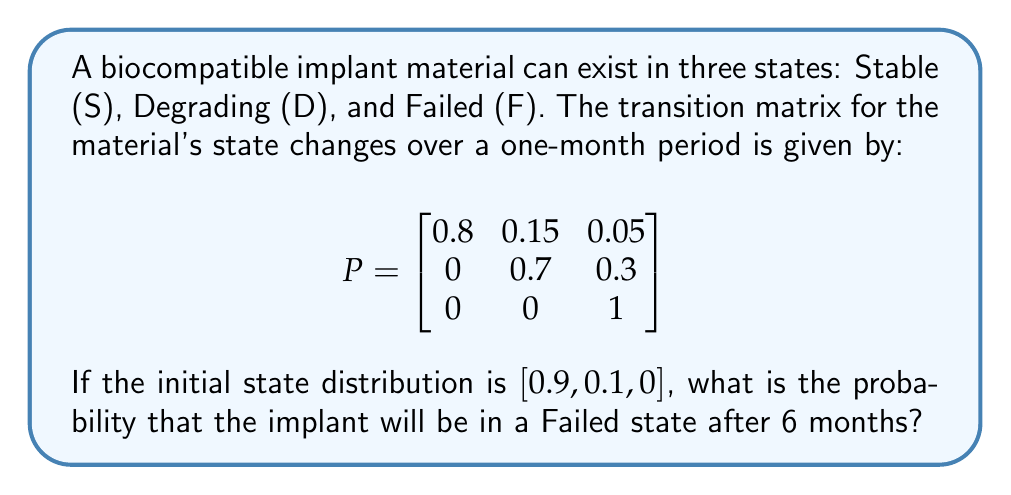Help me with this question. To solve this problem, we need to use the Markov chain properties and matrix multiplication:

1) Let's denote the initial state vector as $v_0 = [0.9, 0.1, 0]$.

2) To find the state after 6 months, we need to multiply the initial state vector by the transition matrix 6 times:

   $v_6 = v_0 \cdot P^6$

3) To calculate $P^6$, we can use the matrix multiplication method repeatedly:

   $P^2 = P \cdot P = \begin{bmatrix}
   0.64 & 0.27 & 0.09 \\
   0 & 0.49 & 0.51 \\
   0 & 0 & 1
   \end{bmatrix}$

   $P^4 = P^2 \cdot P^2 = \begin{bmatrix}
   0.4096 & 0.3468 & 0.2436 \\
   0 & 0.2401 & 0.7599 \\
   0 & 0 & 1
   \end{bmatrix}$

   $P^6 = P^4 \cdot P^2 = \begin{bmatrix}
   0.2622 & 0.3305 & 0.4073 \\
   0 & 0.1176 & 0.8824 \\
   0 & 0 & 1
   \end{bmatrix}$

4) Now, we multiply the initial state vector by $P^6$:

   $v_6 = [0.9, 0.1, 0] \cdot \begin{bmatrix}
   0.2622 & 0.3305 & 0.4073 \\
   0 & 0.1176 & 0.8824 \\
   0 & 0 & 1
   \end{bmatrix}$

   $v_6 = [0.2360, 0.3097, 0.4543]$

5) The probability of being in the Failed state after 6 months is the third component of $v_6$, which is 0.4543 or approximately 45.43%.
Answer: 0.4543 